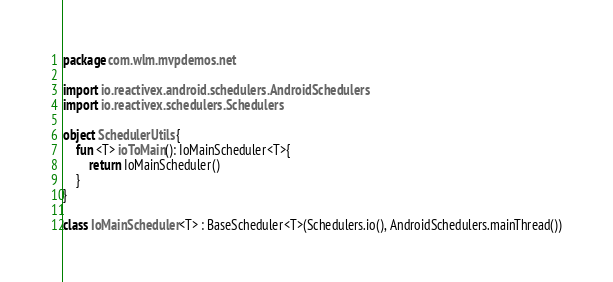<code> <loc_0><loc_0><loc_500><loc_500><_Kotlin_>package com.wlm.mvpdemos.net

import io.reactivex.android.schedulers.AndroidSchedulers
import io.reactivex.schedulers.Schedulers

object SchedulerUtils {
    fun <T> ioToMain(): IoMainScheduler<T>{
        return IoMainScheduler()
    }
}

class IoMainScheduler<T> : BaseScheduler<T>(Schedulers.io(), AndroidSchedulers.mainThread())

</code> 